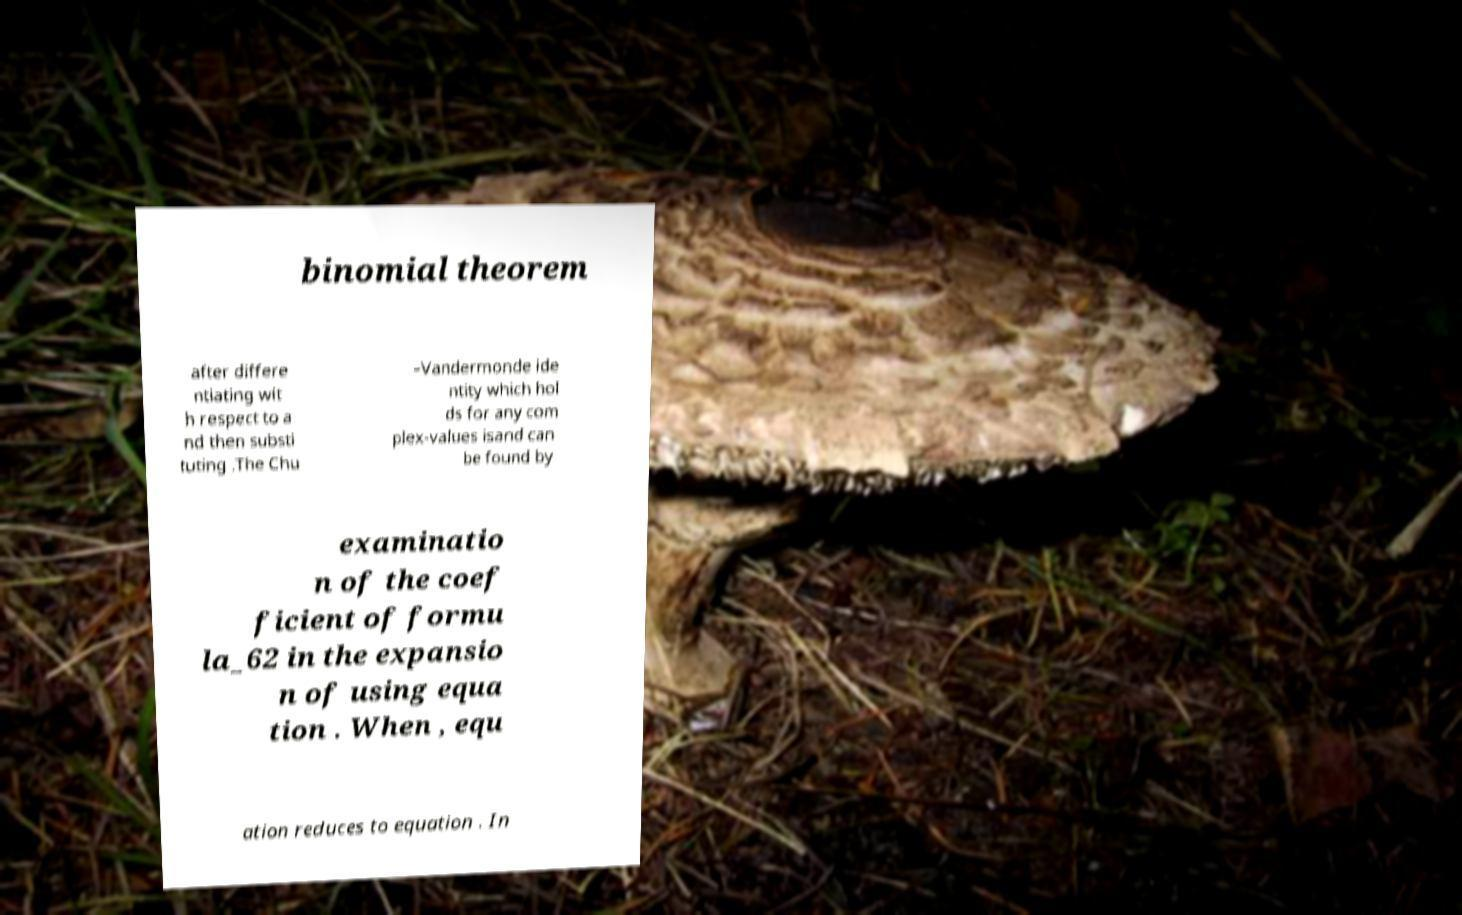Could you extract and type out the text from this image? binomial theorem after differe ntiating wit h respect to a nd then substi tuting .The Chu –Vandermonde ide ntity which hol ds for any com plex-values isand can be found by examinatio n of the coef ficient of formu la_62 in the expansio n of using equa tion . When , equ ation reduces to equation . In 